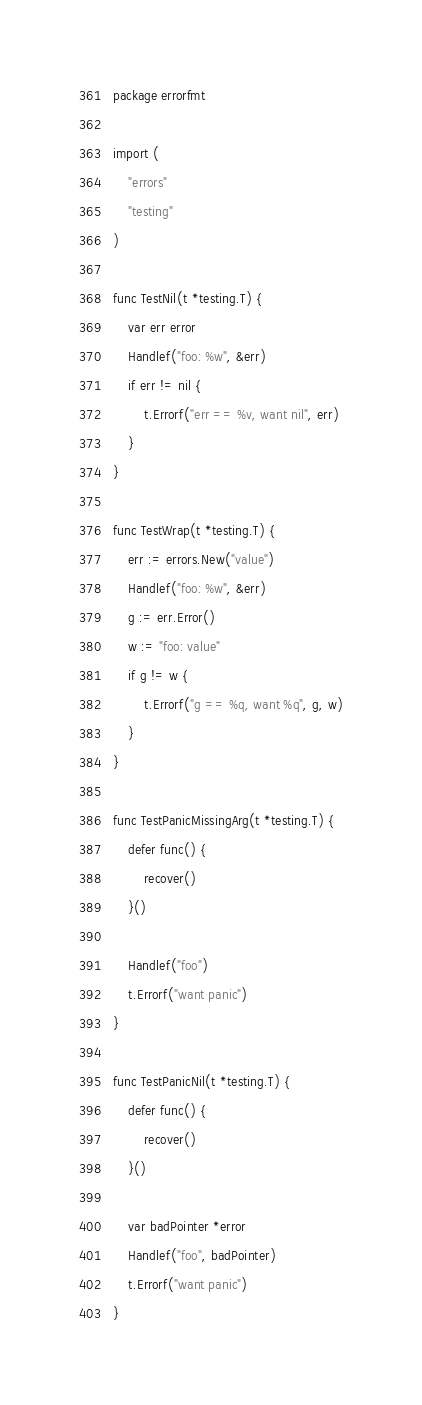Convert code to text. <code><loc_0><loc_0><loc_500><loc_500><_Go_>package errorfmt

import (
	"errors"
	"testing"
)

func TestNil(t *testing.T) {
	var err error
	Handlef("foo: %w", &err)
	if err != nil {
		t.Errorf("err == %v, want nil", err)
	}
}

func TestWrap(t *testing.T) {
	err := errors.New("value")
	Handlef("foo: %w", &err)
	g := err.Error()
	w := "foo: value"
	if g != w {
		t.Errorf("g == %q, want %q", g, w)
	}
}

func TestPanicMissingArg(t *testing.T) {
	defer func() {
		recover()
	}()

	Handlef("foo")
	t.Errorf("want panic")
}

func TestPanicNil(t *testing.T) {
	defer func() {
		recover()
	}()

	var badPointer *error
	Handlef("foo", badPointer)
	t.Errorf("want panic")
}
</code> 